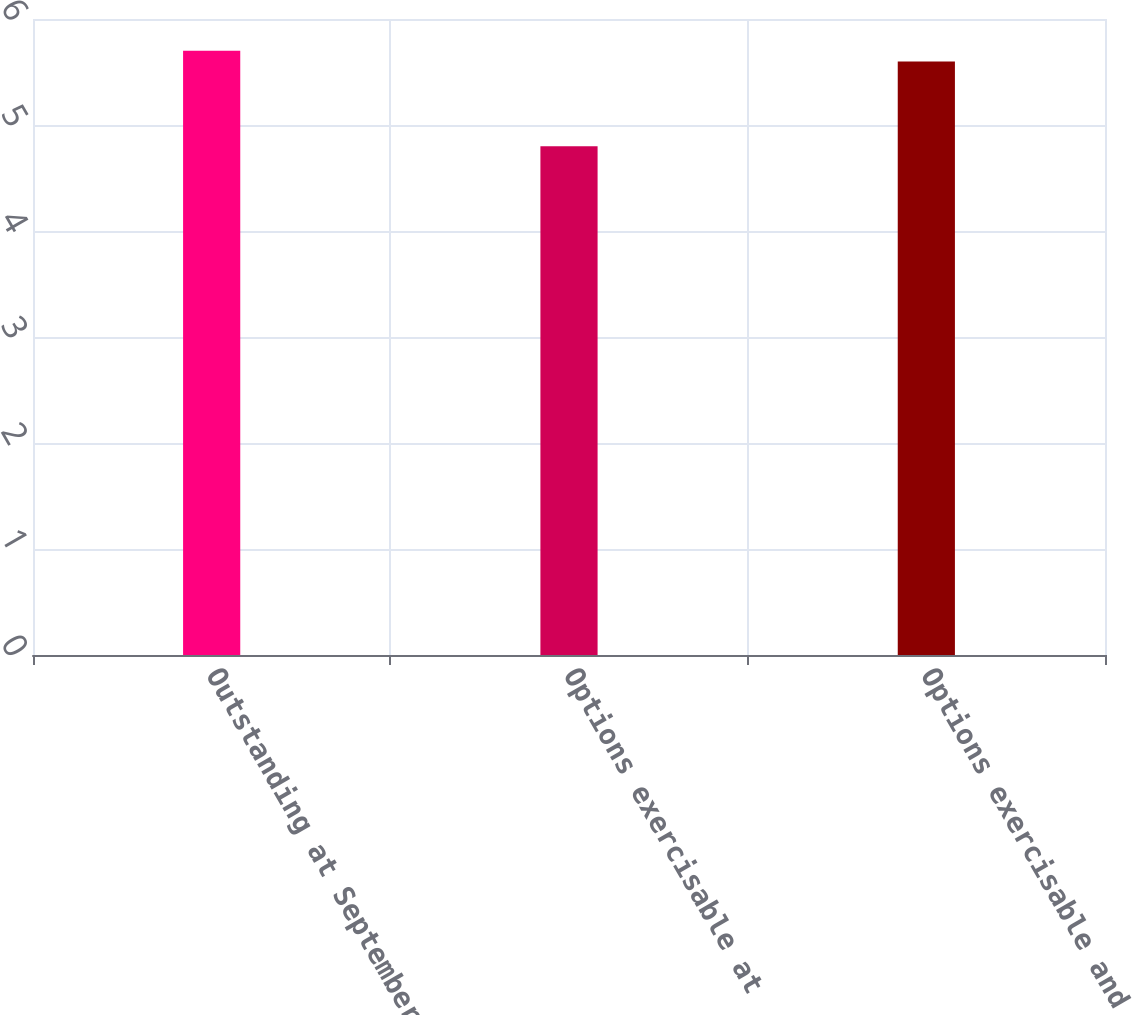Convert chart to OTSL. <chart><loc_0><loc_0><loc_500><loc_500><bar_chart><fcel>Outstanding at September 30<fcel>Options exercisable at<fcel>Options exercisable and<nl><fcel>5.7<fcel>4.8<fcel>5.6<nl></chart> 